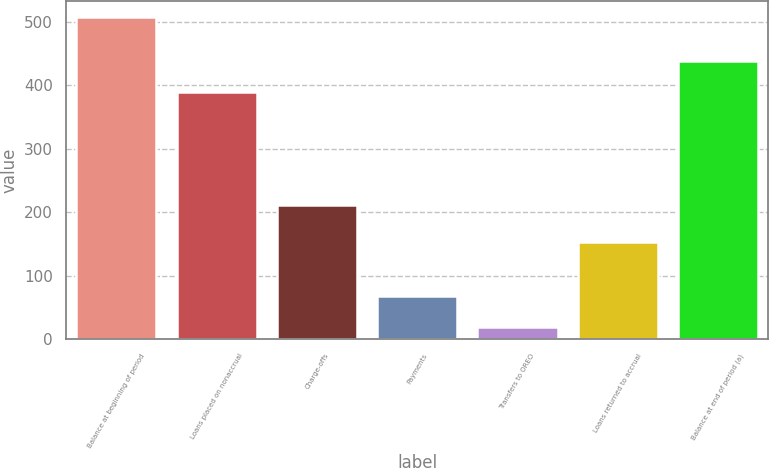<chart> <loc_0><loc_0><loc_500><loc_500><bar_chart><fcel>Balance at beginning of period<fcel>Loans placed on nonaccrual<fcel>Charge-offs<fcel>Payments<fcel>Transfers to OREO<fcel>Loans returned to accrual<fcel>Balance at end of period (a)<nl><fcel>508<fcel>389<fcel>211<fcel>68.8<fcel>20<fcel>154<fcel>437.8<nl></chart> 